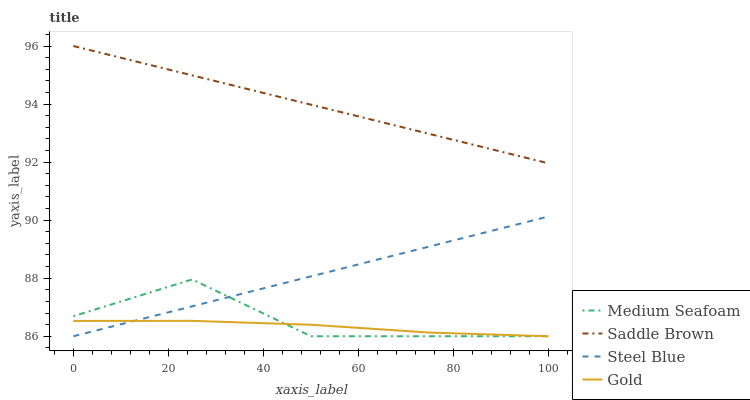Does Gold have the minimum area under the curve?
Answer yes or no. Yes. Does Saddle Brown have the maximum area under the curve?
Answer yes or no. Yes. Does Medium Seafoam have the minimum area under the curve?
Answer yes or no. No. Does Medium Seafoam have the maximum area under the curve?
Answer yes or no. No. Is Steel Blue the smoothest?
Answer yes or no. Yes. Is Medium Seafoam the roughest?
Answer yes or no. Yes. Is Gold the smoothest?
Answer yes or no. No. Is Gold the roughest?
Answer yes or no. No. Does Steel Blue have the lowest value?
Answer yes or no. Yes. Does Saddle Brown have the lowest value?
Answer yes or no. No. Does Saddle Brown have the highest value?
Answer yes or no. Yes. Does Medium Seafoam have the highest value?
Answer yes or no. No. Is Gold less than Saddle Brown?
Answer yes or no. Yes. Is Saddle Brown greater than Gold?
Answer yes or no. Yes. Does Medium Seafoam intersect Steel Blue?
Answer yes or no. Yes. Is Medium Seafoam less than Steel Blue?
Answer yes or no. No. Is Medium Seafoam greater than Steel Blue?
Answer yes or no. No. Does Gold intersect Saddle Brown?
Answer yes or no. No. 